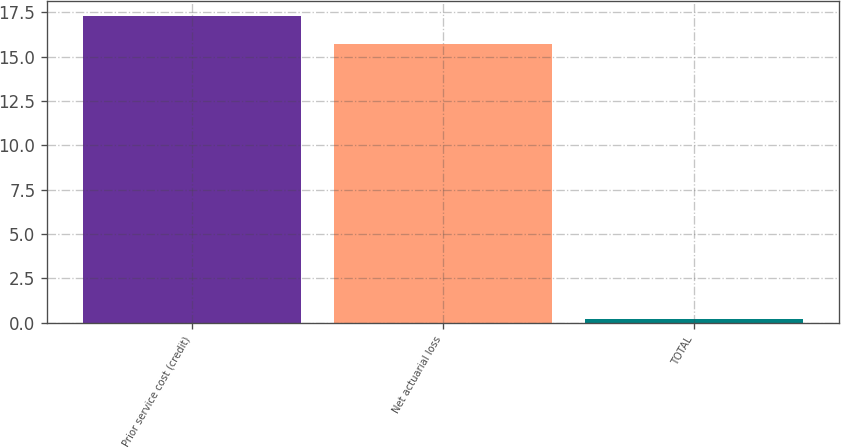Convert chart. <chart><loc_0><loc_0><loc_500><loc_500><bar_chart><fcel>Prior service cost (credit)<fcel>Net actuarial loss<fcel>TOTAL<nl><fcel>17.27<fcel>15.7<fcel>0.2<nl></chart> 